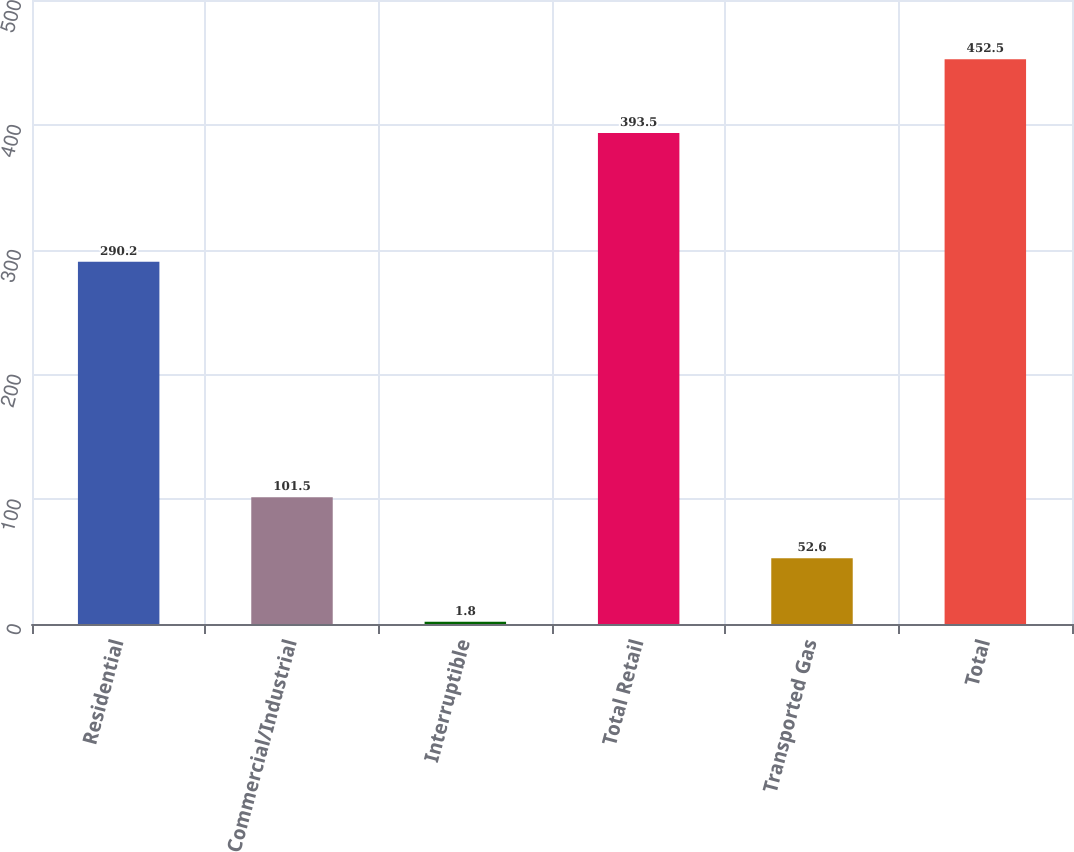Convert chart to OTSL. <chart><loc_0><loc_0><loc_500><loc_500><bar_chart><fcel>Residential<fcel>Commercial/Industrial<fcel>Interruptible<fcel>Total Retail<fcel>Transported Gas<fcel>Total<nl><fcel>290.2<fcel>101.5<fcel>1.8<fcel>393.5<fcel>52.6<fcel>452.5<nl></chart> 